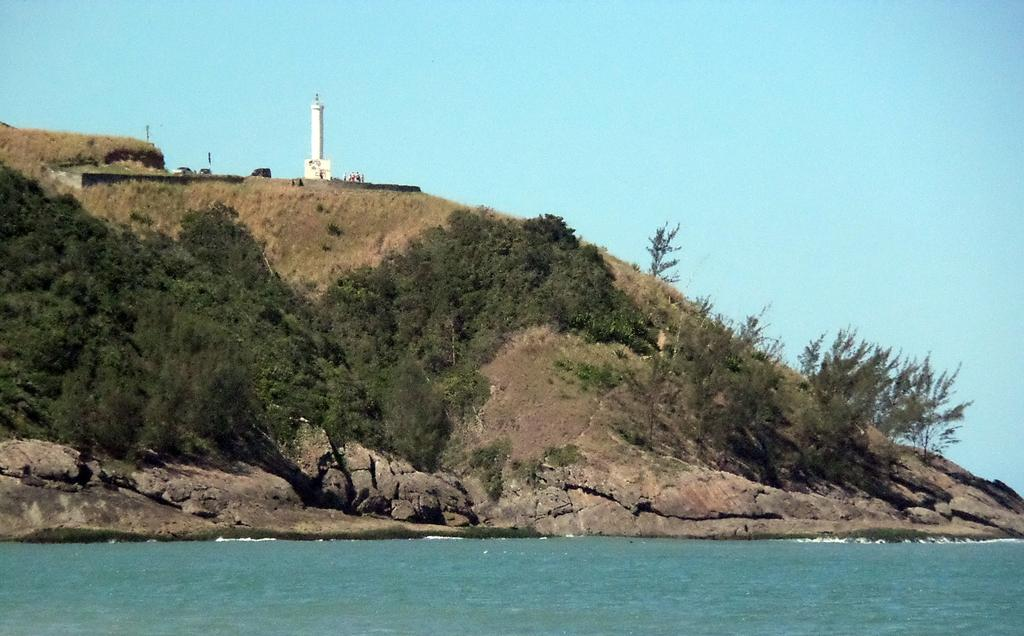What is the main structure in the image? There is a tower in the image. Can you describe the people in the image? There is a group of people in the image. What can be seen on the hill in the image? There are poles on the hill in the image. What type of vegetation is present in the image? There is a group of trees and plants in the image. What is the large body of water in the image? There is a large water body in the image. What is visible in the sky in the image? The sky is visible in the image. How many oranges are being carried by the yak in the image? There is no yak or orange present in the image. 